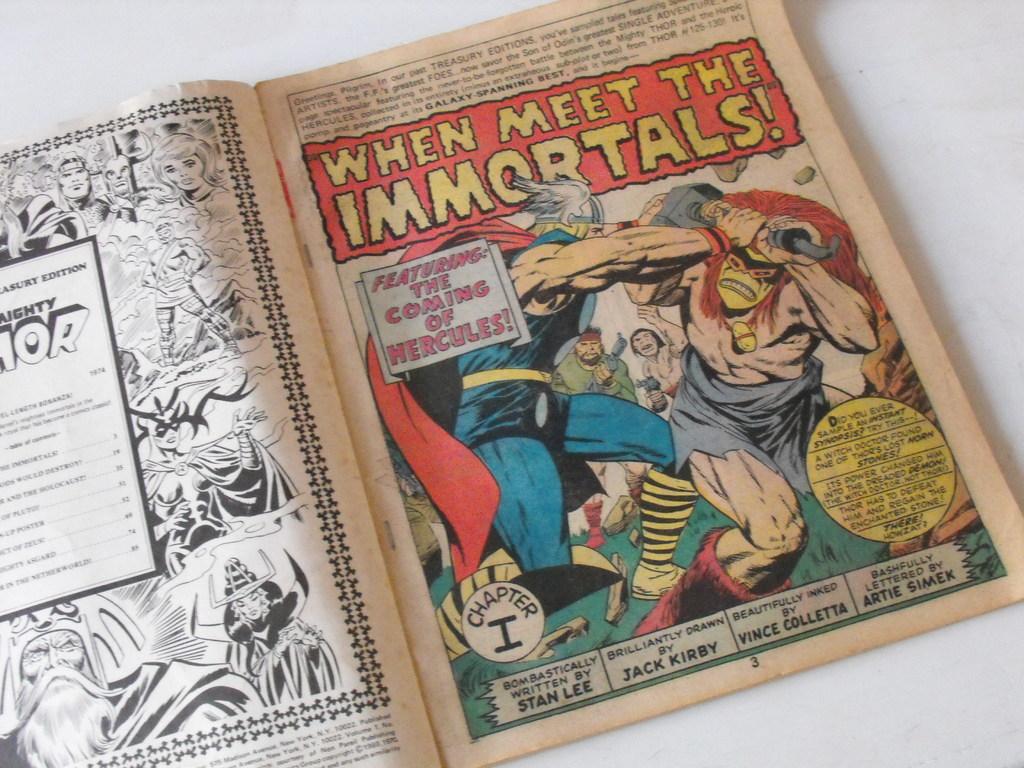Who is the artist who drew the cartoons?
Ensure brevity in your answer.  Jack kirby. 